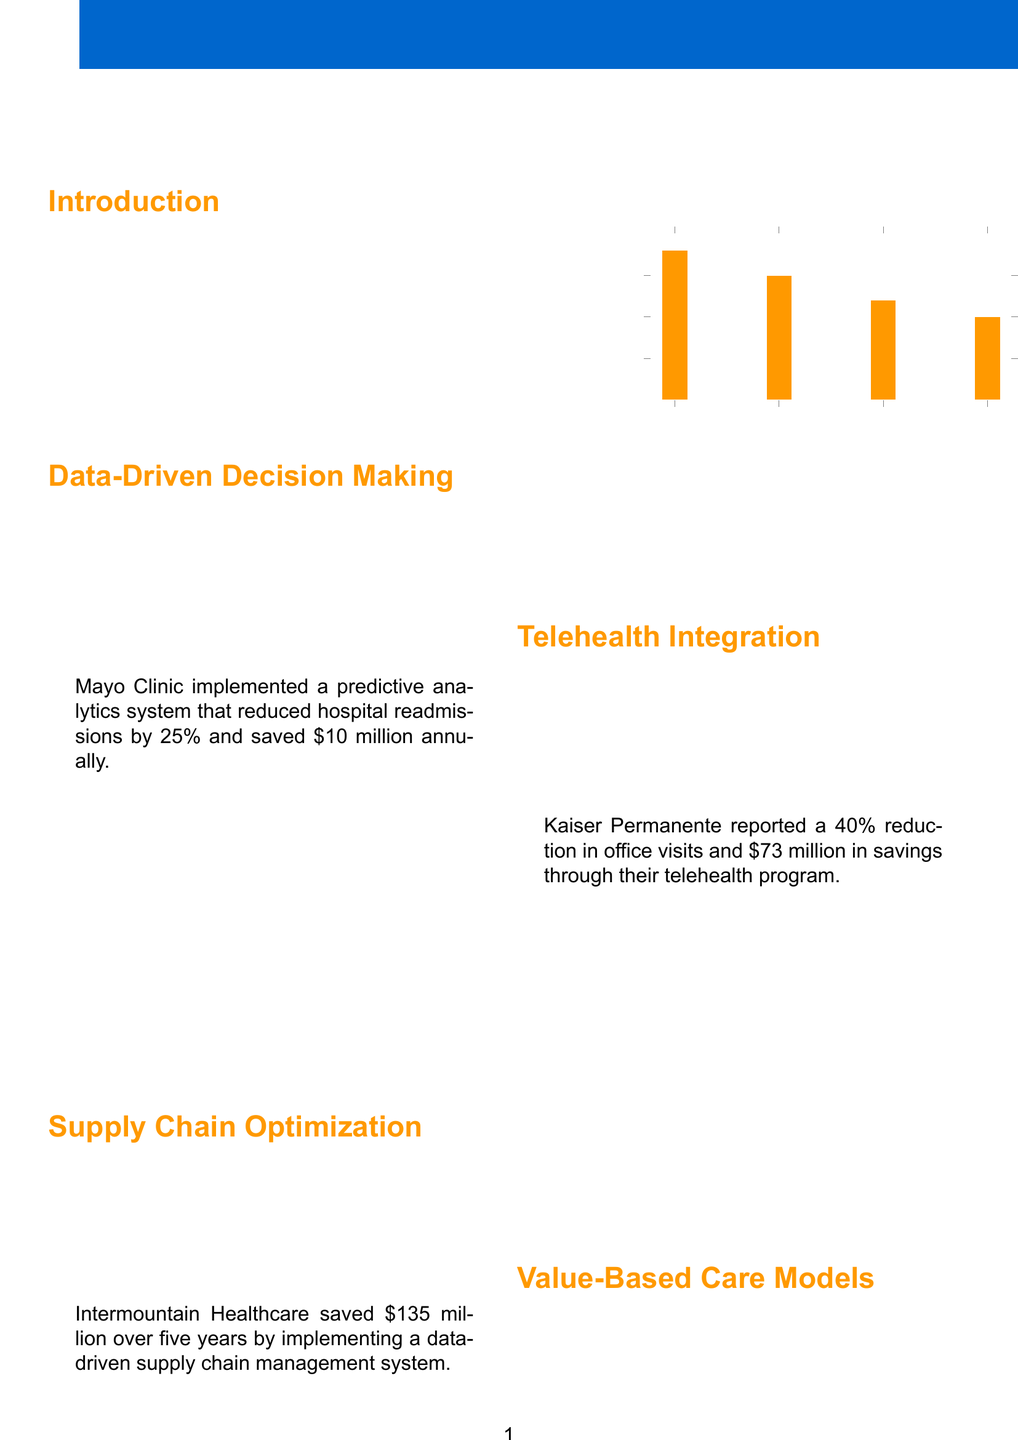what is the title of the brochure? The title appears at the top of the document and provides an overview of its content.
Answer: Healthcare Cost Reduction Strategies: Innovative Approaches for Financial Efficiency how much did Mayo Clinic save annually through their predictive analytics? This information is found in the case study on data-driven decision making.
Answer: $10 million what percentage did Kaiser Permanente report for a reduction in office visits? This statistic is included in the telehealth integration case study.
Answer: 40% what was the savings amount for Intermountain Healthcare over five years? This figure is stated in the supply chain optimization case study.
Answer: $135 million which initiative had the highest ROI percentage? This can be determined from the chart on preventive care initiatives showing ROI values.
Answer: Smoking Cessation what are the 5S principles in healthcare? This list is provided under the lean management principles section, detailing the specific principles.
Answer: Sort, Set in Order, Shine, Standardize, Sustain how many case studies are included in the brochure? This can be inferred by counting the case studies mentioned throughout the sections.
Answer: 6 which healthcare financial analyst authored the brochure? This information can be found in the author section at the end of the document.
Answer: Jane Doe, CPA, CHFP what type of care models does the brochure recommend transitioning to? This is outlined in the section discussing value-based care models.
Answer: Value-based care models 